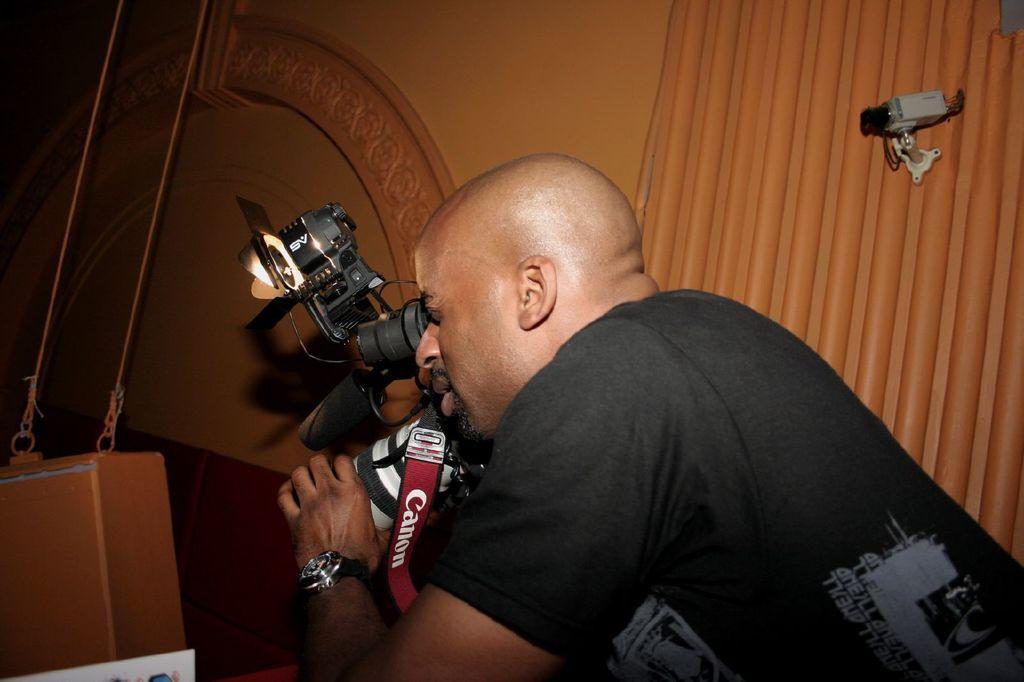How would you summarize this image in a sentence or two? In this image I can see a man and he is wearing a black t-shirt. I can also see he is holding a camera and a tag is with camera. Here on this wall I can see a CCTV. 